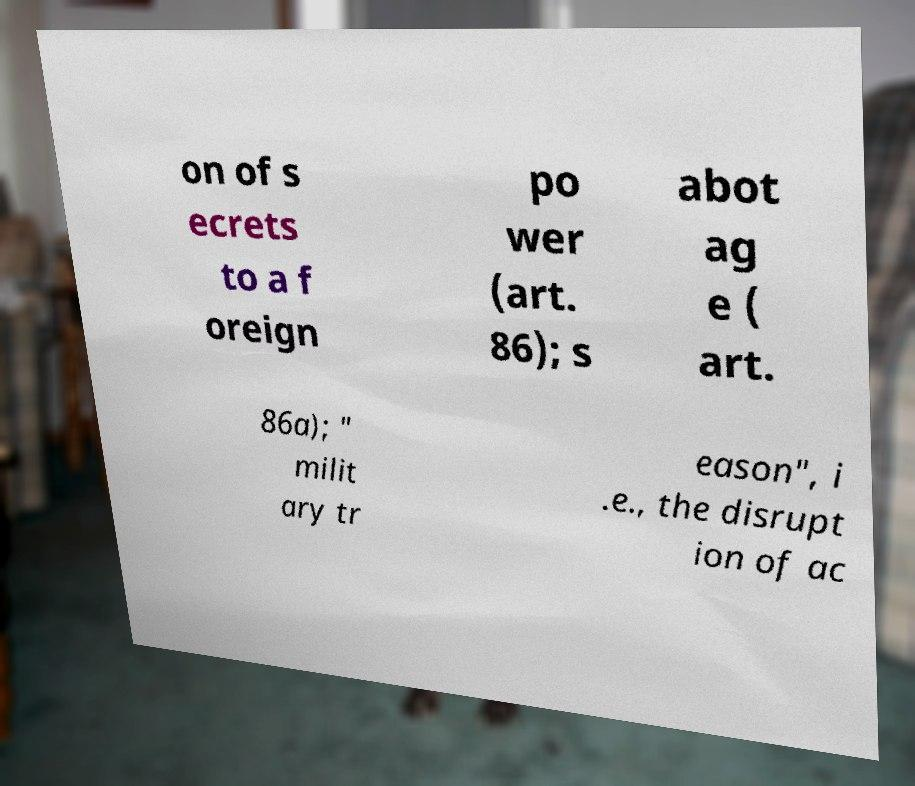Can you accurately transcribe the text from the provided image for me? on of s ecrets to a f oreign po wer (art. 86); s abot ag e ( art. 86a); " milit ary tr eason", i .e., the disrupt ion of ac 